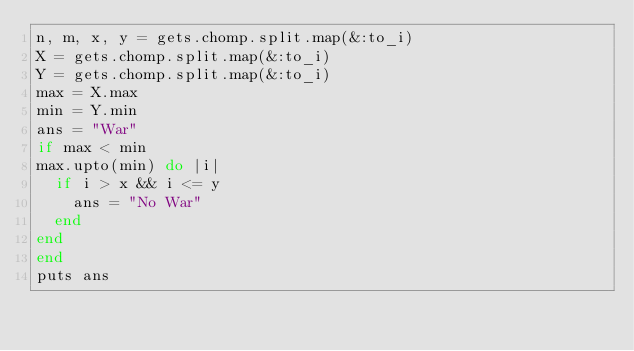Convert code to text. <code><loc_0><loc_0><loc_500><loc_500><_Ruby_>n, m, x, y = gets.chomp.split.map(&:to_i)
X = gets.chomp.split.map(&:to_i)
Y = gets.chomp.split.map(&:to_i)
max = X.max
min = Y.min
ans = "War"
if max < min
max.upto(min) do |i|
  if i > x && i <= y
    ans = "No War"
  end
end
end
puts ans</code> 